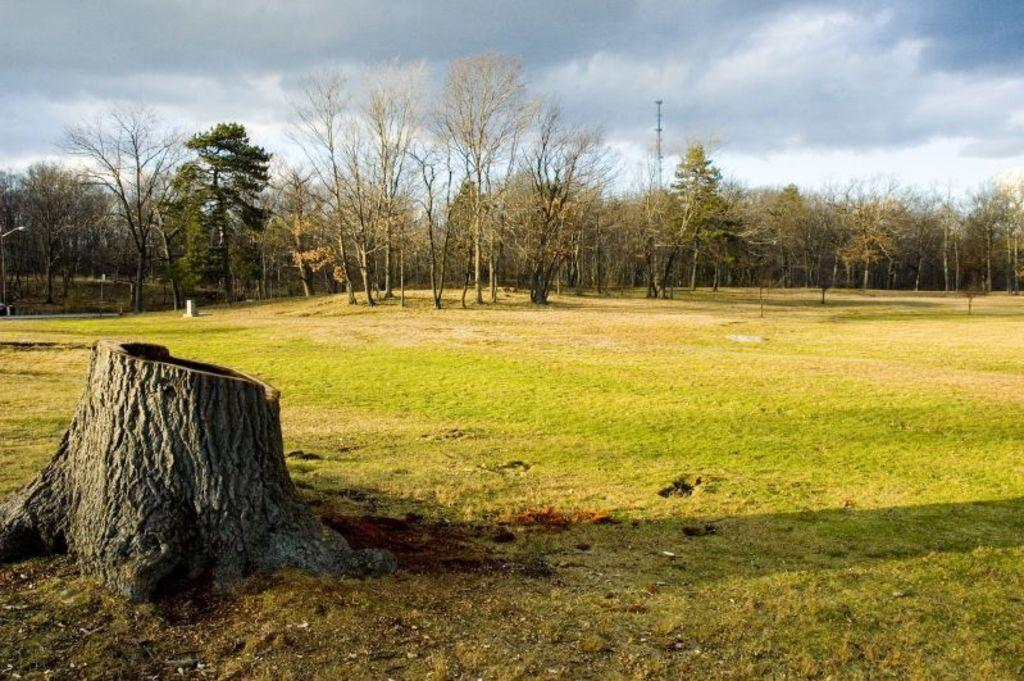What object is located on the ground on the left side of the image? There is a trunk on the ground on the left side of the image. What can be seen in the background of the image? There are trees and a pole in the background of the image. What is visible in the sky in the background of the image? There are clouds in the sky in the background of the image. What is the source of light on the left side of the image? There is a light on the left side of the image. What type of pie is being served on the trunk in the image? There is no pie present in the image; it features a trunk on the ground. Is there a coat hanging on the pole in the background of the image? There is no coat visible on the pole in the background of the image. 